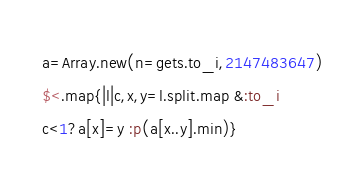<code> <loc_0><loc_0><loc_500><loc_500><_Ruby_>a=Array.new(n=gets.to_i,2147483647)
$<.map{|l|c,x,y=l.split.map &:to_i
c<1?a[x]=y :p(a[x..y].min)}</code> 